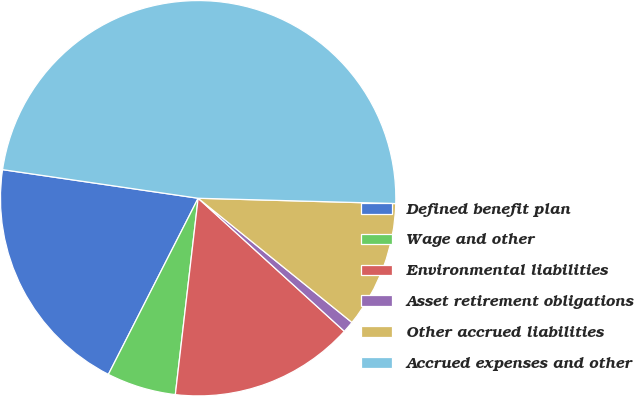Convert chart to OTSL. <chart><loc_0><loc_0><loc_500><loc_500><pie_chart><fcel>Defined benefit plan<fcel>Wage and other<fcel>Environmental liabilities<fcel>Asset retirement obligations<fcel>Other accrued liabilities<fcel>Accrued expenses and other<nl><fcel>19.81%<fcel>5.66%<fcel>15.09%<fcel>0.94%<fcel>10.38%<fcel>48.12%<nl></chart> 